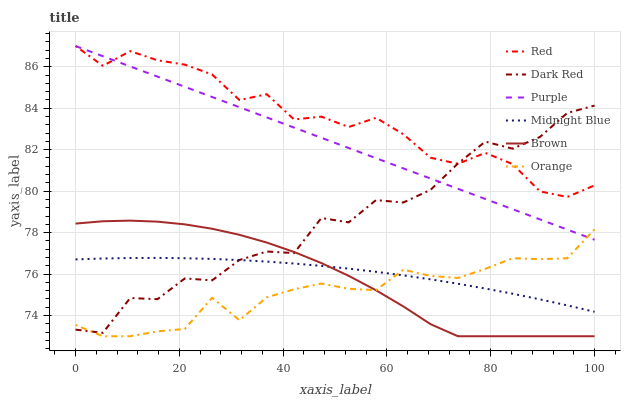Does Orange have the minimum area under the curve?
Answer yes or no. Yes. Does Red have the maximum area under the curve?
Answer yes or no. Yes. Does Midnight Blue have the minimum area under the curve?
Answer yes or no. No. Does Midnight Blue have the maximum area under the curve?
Answer yes or no. No. Is Purple the smoothest?
Answer yes or no. Yes. Is Dark Red the roughest?
Answer yes or no. Yes. Is Midnight Blue the smoothest?
Answer yes or no. No. Is Midnight Blue the roughest?
Answer yes or no. No. Does Brown have the lowest value?
Answer yes or no. Yes. Does Midnight Blue have the lowest value?
Answer yes or no. No. Does Red have the highest value?
Answer yes or no. Yes. Does Midnight Blue have the highest value?
Answer yes or no. No. Is Brown less than Purple?
Answer yes or no. Yes. Is Purple greater than Midnight Blue?
Answer yes or no. Yes. Does Dark Red intersect Brown?
Answer yes or no. Yes. Is Dark Red less than Brown?
Answer yes or no. No. Is Dark Red greater than Brown?
Answer yes or no. No. Does Brown intersect Purple?
Answer yes or no. No. 